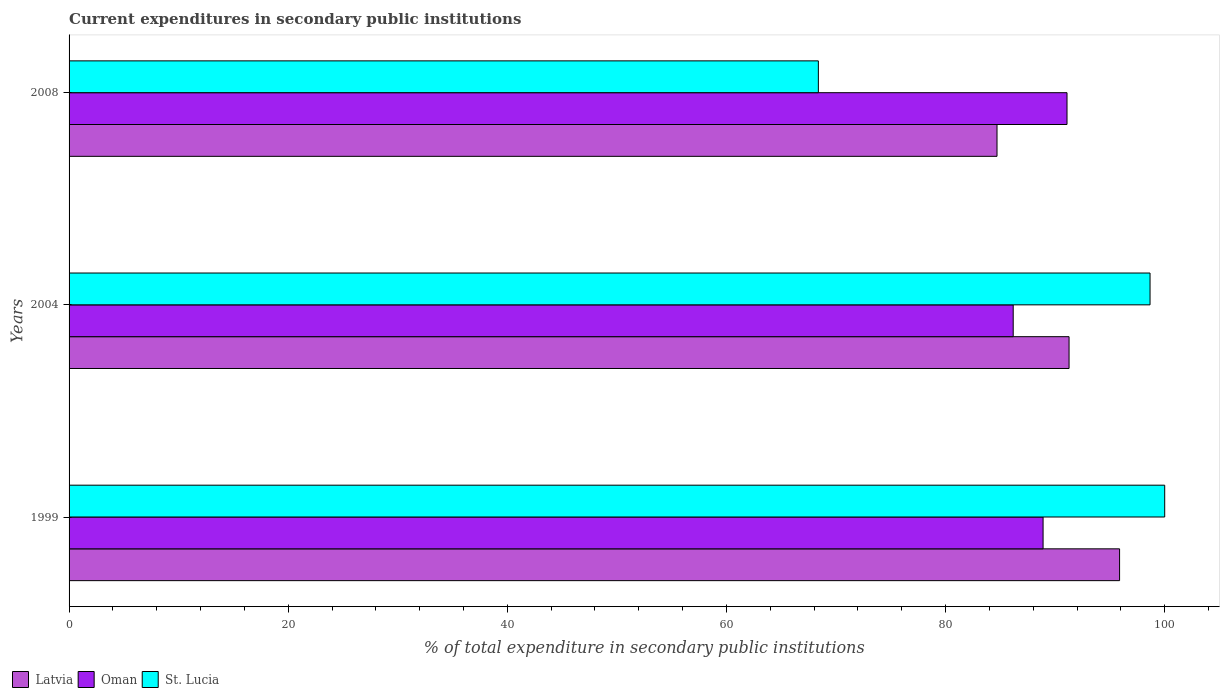Are the number of bars per tick equal to the number of legend labels?
Your answer should be very brief. Yes. How many bars are there on the 3rd tick from the top?
Keep it short and to the point. 3. What is the current expenditures in secondary public institutions in Oman in 1999?
Your answer should be compact. 88.9. Across all years, what is the maximum current expenditures in secondary public institutions in St. Lucia?
Give a very brief answer. 100. Across all years, what is the minimum current expenditures in secondary public institutions in Latvia?
Keep it short and to the point. 84.69. In which year was the current expenditures in secondary public institutions in Latvia maximum?
Make the answer very short. 1999. In which year was the current expenditures in secondary public institutions in Latvia minimum?
Keep it short and to the point. 2008. What is the total current expenditures in secondary public institutions in Latvia in the graph?
Your answer should be compact. 271.84. What is the difference between the current expenditures in secondary public institutions in Oman in 2004 and that in 2008?
Give a very brief answer. -4.91. What is the difference between the current expenditures in secondary public institutions in Latvia in 2004 and the current expenditures in secondary public institutions in Oman in 2008?
Provide a succinct answer. 0.19. What is the average current expenditures in secondary public institutions in Latvia per year?
Give a very brief answer. 90.61. In the year 2008, what is the difference between the current expenditures in secondary public institutions in Oman and current expenditures in secondary public institutions in St. Lucia?
Make the answer very short. 22.69. What is the ratio of the current expenditures in secondary public institutions in Latvia in 2004 to that in 2008?
Your answer should be very brief. 1.08. Is the difference between the current expenditures in secondary public institutions in Oman in 1999 and 2008 greater than the difference between the current expenditures in secondary public institutions in St. Lucia in 1999 and 2008?
Your answer should be very brief. No. What is the difference between the highest and the second highest current expenditures in secondary public institutions in Latvia?
Offer a very short reply. 4.61. What is the difference between the highest and the lowest current expenditures in secondary public institutions in St. Lucia?
Make the answer very short. 31.61. Is the sum of the current expenditures in secondary public institutions in St. Lucia in 1999 and 2008 greater than the maximum current expenditures in secondary public institutions in Oman across all years?
Make the answer very short. Yes. What does the 3rd bar from the top in 2008 represents?
Offer a terse response. Latvia. What does the 1st bar from the bottom in 1999 represents?
Your answer should be compact. Latvia. Is it the case that in every year, the sum of the current expenditures in secondary public institutions in Latvia and current expenditures in secondary public institutions in St. Lucia is greater than the current expenditures in secondary public institutions in Oman?
Your answer should be compact. Yes. Are all the bars in the graph horizontal?
Your answer should be very brief. Yes. How many years are there in the graph?
Your answer should be compact. 3. Does the graph contain any zero values?
Provide a short and direct response. No. Does the graph contain grids?
Keep it short and to the point. No. How many legend labels are there?
Ensure brevity in your answer.  3. How are the legend labels stacked?
Provide a succinct answer. Horizontal. What is the title of the graph?
Your answer should be compact. Current expenditures in secondary public institutions. Does "Liberia" appear as one of the legend labels in the graph?
Keep it short and to the point. No. What is the label or title of the X-axis?
Your answer should be compact. % of total expenditure in secondary public institutions. What is the % of total expenditure in secondary public institutions in Latvia in 1999?
Give a very brief answer. 95.88. What is the % of total expenditure in secondary public institutions in Oman in 1999?
Keep it short and to the point. 88.9. What is the % of total expenditure in secondary public institutions of Latvia in 2004?
Offer a very short reply. 91.27. What is the % of total expenditure in secondary public institutions in Oman in 2004?
Offer a terse response. 86.17. What is the % of total expenditure in secondary public institutions of St. Lucia in 2004?
Offer a terse response. 98.66. What is the % of total expenditure in secondary public institutions in Latvia in 2008?
Ensure brevity in your answer.  84.69. What is the % of total expenditure in secondary public institutions of Oman in 2008?
Give a very brief answer. 91.08. What is the % of total expenditure in secondary public institutions in St. Lucia in 2008?
Your answer should be compact. 68.39. Across all years, what is the maximum % of total expenditure in secondary public institutions in Latvia?
Ensure brevity in your answer.  95.88. Across all years, what is the maximum % of total expenditure in secondary public institutions in Oman?
Provide a succinct answer. 91.08. Across all years, what is the maximum % of total expenditure in secondary public institutions of St. Lucia?
Provide a short and direct response. 100. Across all years, what is the minimum % of total expenditure in secondary public institutions of Latvia?
Your response must be concise. 84.69. Across all years, what is the minimum % of total expenditure in secondary public institutions in Oman?
Your answer should be compact. 86.17. Across all years, what is the minimum % of total expenditure in secondary public institutions of St. Lucia?
Give a very brief answer. 68.39. What is the total % of total expenditure in secondary public institutions in Latvia in the graph?
Give a very brief answer. 271.84. What is the total % of total expenditure in secondary public institutions of Oman in the graph?
Make the answer very short. 266.15. What is the total % of total expenditure in secondary public institutions in St. Lucia in the graph?
Your answer should be very brief. 267.05. What is the difference between the % of total expenditure in secondary public institutions in Latvia in 1999 and that in 2004?
Give a very brief answer. 4.61. What is the difference between the % of total expenditure in secondary public institutions in Oman in 1999 and that in 2004?
Provide a succinct answer. 2.73. What is the difference between the % of total expenditure in secondary public institutions in St. Lucia in 1999 and that in 2004?
Offer a terse response. 1.34. What is the difference between the % of total expenditure in secondary public institutions of Latvia in 1999 and that in 2008?
Your answer should be compact. 11.19. What is the difference between the % of total expenditure in secondary public institutions of Oman in 1999 and that in 2008?
Provide a succinct answer. -2.18. What is the difference between the % of total expenditure in secondary public institutions in St. Lucia in 1999 and that in 2008?
Ensure brevity in your answer.  31.61. What is the difference between the % of total expenditure in secondary public institutions of Latvia in 2004 and that in 2008?
Give a very brief answer. 6.58. What is the difference between the % of total expenditure in secondary public institutions of Oman in 2004 and that in 2008?
Offer a terse response. -4.91. What is the difference between the % of total expenditure in secondary public institutions of St. Lucia in 2004 and that in 2008?
Provide a short and direct response. 30.27. What is the difference between the % of total expenditure in secondary public institutions in Latvia in 1999 and the % of total expenditure in secondary public institutions in Oman in 2004?
Ensure brevity in your answer.  9.71. What is the difference between the % of total expenditure in secondary public institutions in Latvia in 1999 and the % of total expenditure in secondary public institutions in St. Lucia in 2004?
Your answer should be compact. -2.78. What is the difference between the % of total expenditure in secondary public institutions in Oman in 1999 and the % of total expenditure in secondary public institutions in St. Lucia in 2004?
Give a very brief answer. -9.76. What is the difference between the % of total expenditure in secondary public institutions of Latvia in 1999 and the % of total expenditure in secondary public institutions of Oman in 2008?
Provide a short and direct response. 4.8. What is the difference between the % of total expenditure in secondary public institutions in Latvia in 1999 and the % of total expenditure in secondary public institutions in St. Lucia in 2008?
Give a very brief answer. 27.49. What is the difference between the % of total expenditure in secondary public institutions in Oman in 1999 and the % of total expenditure in secondary public institutions in St. Lucia in 2008?
Offer a terse response. 20.51. What is the difference between the % of total expenditure in secondary public institutions of Latvia in 2004 and the % of total expenditure in secondary public institutions of Oman in 2008?
Your answer should be very brief. 0.19. What is the difference between the % of total expenditure in secondary public institutions of Latvia in 2004 and the % of total expenditure in secondary public institutions of St. Lucia in 2008?
Keep it short and to the point. 22.88. What is the difference between the % of total expenditure in secondary public institutions of Oman in 2004 and the % of total expenditure in secondary public institutions of St. Lucia in 2008?
Provide a short and direct response. 17.78. What is the average % of total expenditure in secondary public institutions in Latvia per year?
Your answer should be very brief. 90.61. What is the average % of total expenditure in secondary public institutions of Oman per year?
Offer a terse response. 88.72. What is the average % of total expenditure in secondary public institutions in St. Lucia per year?
Offer a terse response. 89.02. In the year 1999, what is the difference between the % of total expenditure in secondary public institutions in Latvia and % of total expenditure in secondary public institutions in Oman?
Provide a short and direct response. 6.98. In the year 1999, what is the difference between the % of total expenditure in secondary public institutions in Latvia and % of total expenditure in secondary public institutions in St. Lucia?
Provide a short and direct response. -4.12. In the year 1999, what is the difference between the % of total expenditure in secondary public institutions in Oman and % of total expenditure in secondary public institutions in St. Lucia?
Provide a succinct answer. -11.1. In the year 2004, what is the difference between the % of total expenditure in secondary public institutions of Latvia and % of total expenditure in secondary public institutions of Oman?
Give a very brief answer. 5.1. In the year 2004, what is the difference between the % of total expenditure in secondary public institutions in Latvia and % of total expenditure in secondary public institutions in St. Lucia?
Your response must be concise. -7.39. In the year 2004, what is the difference between the % of total expenditure in secondary public institutions of Oman and % of total expenditure in secondary public institutions of St. Lucia?
Provide a short and direct response. -12.49. In the year 2008, what is the difference between the % of total expenditure in secondary public institutions of Latvia and % of total expenditure in secondary public institutions of Oman?
Your answer should be compact. -6.39. In the year 2008, what is the difference between the % of total expenditure in secondary public institutions of Latvia and % of total expenditure in secondary public institutions of St. Lucia?
Offer a very short reply. 16.31. In the year 2008, what is the difference between the % of total expenditure in secondary public institutions in Oman and % of total expenditure in secondary public institutions in St. Lucia?
Your answer should be compact. 22.69. What is the ratio of the % of total expenditure in secondary public institutions in Latvia in 1999 to that in 2004?
Offer a terse response. 1.05. What is the ratio of the % of total expenditure in secondary public institutions of Oman in 1999 to that in 2004?
Your answer should be compact. 1.03. What is the ratio of the % of total expenditure in secondary public institutions in St. Lucia in 1999 to that in 2004?
Provide a short and direct response. 1.01. What is the ratio of the % of total expenditure in secondary public institutions of Latvia in 1999 to that in 2008?
Your answer should be compact. 1.13. What is the ratio of the % of total expenditure in secondary public institutions in Oman in 1999 to that in 2008?
Provide a succinct answer. 0.98. What is the ratio of the % of total expenditure in secondary public institutions in St. Lucia in 1999 to that in 2008?
Provide a short and direct response. 1.46. What is the ratio of the % of total expenditure in secondary public institutions of Latvia in 2004 to that in 2008?
Give a very brief answer. 1.08. What is the ratio of the % of total expenditure in secondary public institutions in Oman in 2004 to that in 2008?
Make the answer very short. 0.95. What is the ratio of the % of total expenditure in secondary public institutions of St. Lucia in 2004 to that in 2008?
Ensure brevity in your answer.  1.44. What is the difference between the highest and the second highest % of total expenditure in secondary public institutions of Latvia?
Provide a short and direct response. 4.61. What is the difference between the highest and the second highest % of total expenditure in secondary public institutions in Oman?
Provide a succinct answer. 2.18. What is the difference between the highest and the second highest % of total expenditure in secondary public institutions in St. Lucia?
Keep it short and to the point. 1.34. What is the difference between the highest and the lowest % of total expenditure in secondary public institutions of Latvia?
Make the answer very short. 11.19. What is the difference between the highest and the lowest % of total expenditure in secondary public institutions of Oman?
Your answer should be compact. 4.91. What is the difference between the highest and the lowest % of total expenditure in secondary public institutions of St. Lucia?
Your answer should be compact. 31.61. 